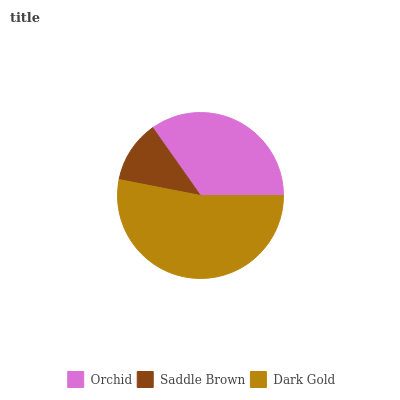Is Saddle Brown the minimum?
Answer yes or no. Yes. Is Dark Gold the maximum?
Answer yes or no. Yes. Is Dark Gold the minimum?
Answer yes or no. No. Is Saddle Brown the maximum?
Answer yes or no. No. Is Dark Gold greater than Saddle Brown?
Answer yes or no. Yes. Is Saddle Brown less than Dark Gold?
Answer yes or no. Yes. Is Saddle Brown greater than Dark Gold?
Answer yes or no. No. Is Dark Gold less than Saddle Brown?
Answer yes or no. No. Is Orchid the high median?
Answer yes or no. Yes. Is Orchid the low median?
Answer yes or no. Yes. Is Dark Gold the high median?
Answer yes or no. No. Is Saddle Brown the low median?
Answer yes or no. No. 